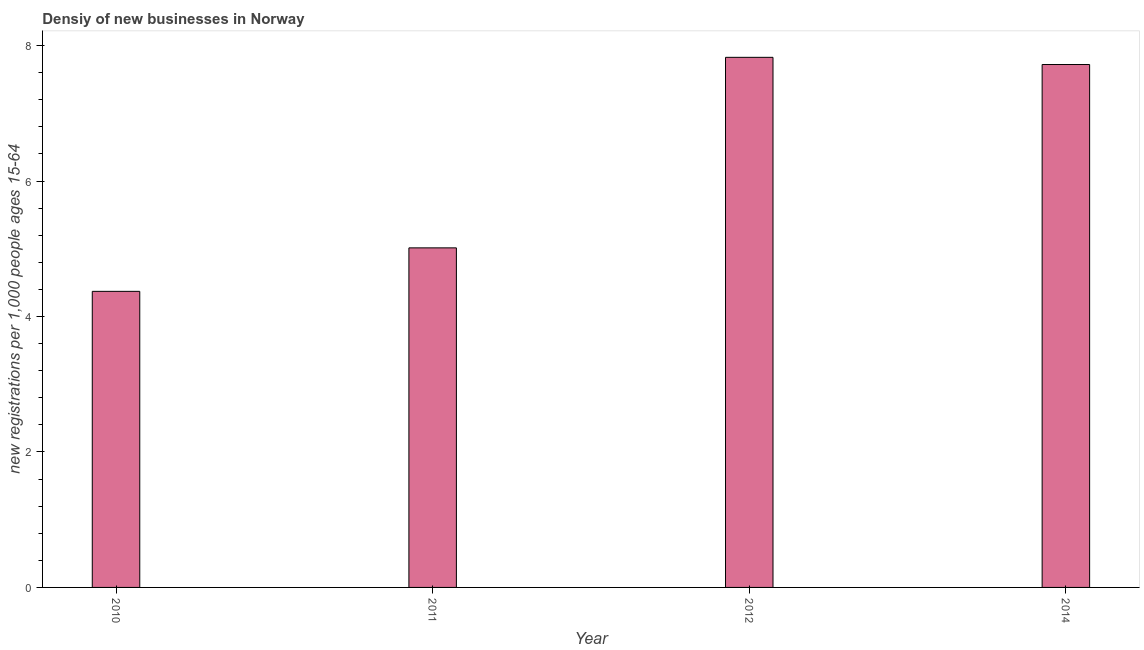Does the graph contain grids?
Offer a terse response. No. What is the title of the graph?
Your response must be concise. Densiy of new businesses in Norway. What is the label or title of the Y-axis?
Offer a very short reply. New registrations per 1,0 people ages 15-64. What is the density of new business in 2010?
Offer a terse response. 4.37. Across all years, what is the maximum density of new business?
Offer a terse response. 7.83. Across all years, what is the minimum density of new business?
Ensure brevity in your answer.  4.37. In which year was the density of new business maximum?
Ensure brevity in your answer.  2012. What is the sum of the density of new business?
Offer a terse response. 24.93. What is the difference between the density of new business in 2011 and 2014?
Provide a short and direct response. -2.71. What is the average density of new business per year?
Your response must be concise. 6.23. What is the median density of new business?
Provide a succinct answer. 6.37. In how many years, is the density of new business greater than 6.4 ?
Offer a very short reply. 2. What is the ratio of the density of new business in 2010 to that in 2012?
Provide a succinct answer. 0.56. Is the density of new business in 2010 less than that in 2014?
Your answer should be compact. Yes. Is the difference between the density of new business in 2010 and 2011 greater than the difference between any two years?
Ensure brevity in your answer.  No. What is the difference between the highest and the second highest density of new business?
Keep it short and to the point. 0.11. Is the sum of the density of new business in 2010 and 2011 greater than the maximum density of new business across all years?
Keep it short and to the point. Yes. What is the difference between the highest and the lowest density of new business?
Offer a very short reply. 3.46. What is the new registrations per 1,000 people ages 15-64 of 2010?
Offer a terse response. 4.37. What is the new registrations per 1,000 people ages 15-64 of 2011?
Keep it short and to the point. 5.01. What is the new registrations per 1,000 people ages 15-64 in 2012?
Your answer should be very brief. 7.83. What is the new registrations per 1,000 people ages 15-64 of 2014?
Provide a short and direct response. 7.72. What is the difference between the new registrations per 1,000 people ages 15-64 in 2010 and 2011?
Your response must be concise. -0.64. What is the difference between the new registrations per 1,000 people ages 15-64 in 2010 and 2012?
Provide a short and direct response. -3.46. What is the difference between the new registrations per 1,000 people ages 15-64 in 2010 and 2014?
Offer a terse response. -3.35. What is the difference between the new registrations per 1,000 people ages 15-64 in 2011 and 2012?
Ensure brevity in your answer.  -2.81. What is the difference between the new registrations per 1,000 people ages 15-64 in 2011 and 2014?
Your answer should be very brief. -2.71. What is the difference between the new registrations per 1,000 people ages 15-64 in 2012 and 2014?
Your answer should be very brief. 0.11. What is the ratio of the new registrations per 1,000 people ages 15-64 in 2010 to that in 2011?
Offer a terse response. 0.87. What is the ratio of the new registrations per 1,000 people ages 15-64 in 2010 to that in 2012?
Keep it short and to the point. 0.56. What is the ratio of the new registrations per 1,000 people ages 15-64 in 2010 to that in 2014?
Your answer should be compact. 0.57. What is the ratio of the new registrations per 1,000 people ages 15-64 in 2011 to that in 2012?
Your answer should be compact. 0.64. What is the ratio of the new registrations per 1,000 people ages 15-64 in 2011 to that in 2014?
Your answer should be compact. 0.65. What is the ratio of the new registrations per 1,000 people ages 15-64 in 2012 to that in 2014?
Your answer should be compact. 1.01. 